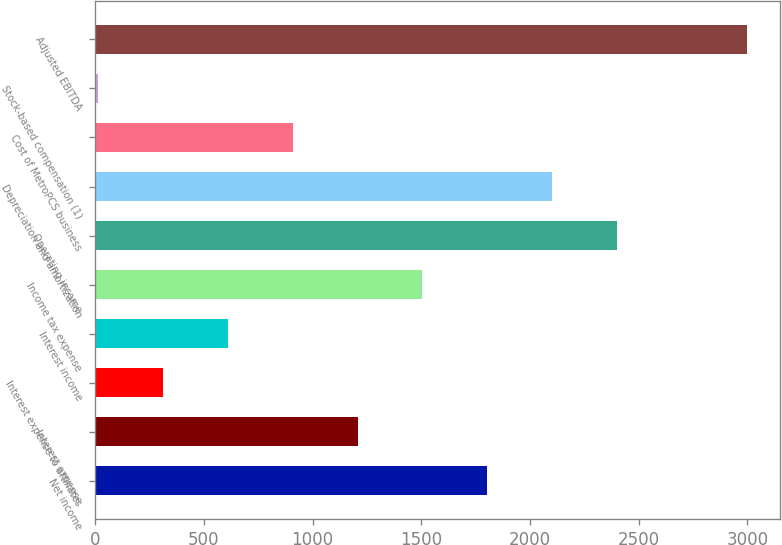Convert chart to OTSL. <chart><loc_0><loc_0><loc_500><loc_500><bar_chart><fcel>Net income<fcel>Interest expense<fcel>Interest expense to affiliates<fcel>Interest income<fcel>Income tax expense<fcel>Operating income<fcel>Depreciation and amortization<fcel>Cost of MetroPCS business<fcel>Stock-based compensation (1)<fcel>Adjusted EBITDA<nl><fcel>1804<fcel>1207<fcel>311.5<fcel>610<fcel>1505.5<fcel>2401<fcel>2102.5<fcel>908.5<fcel>13<fcel>2998<nl></chart> 